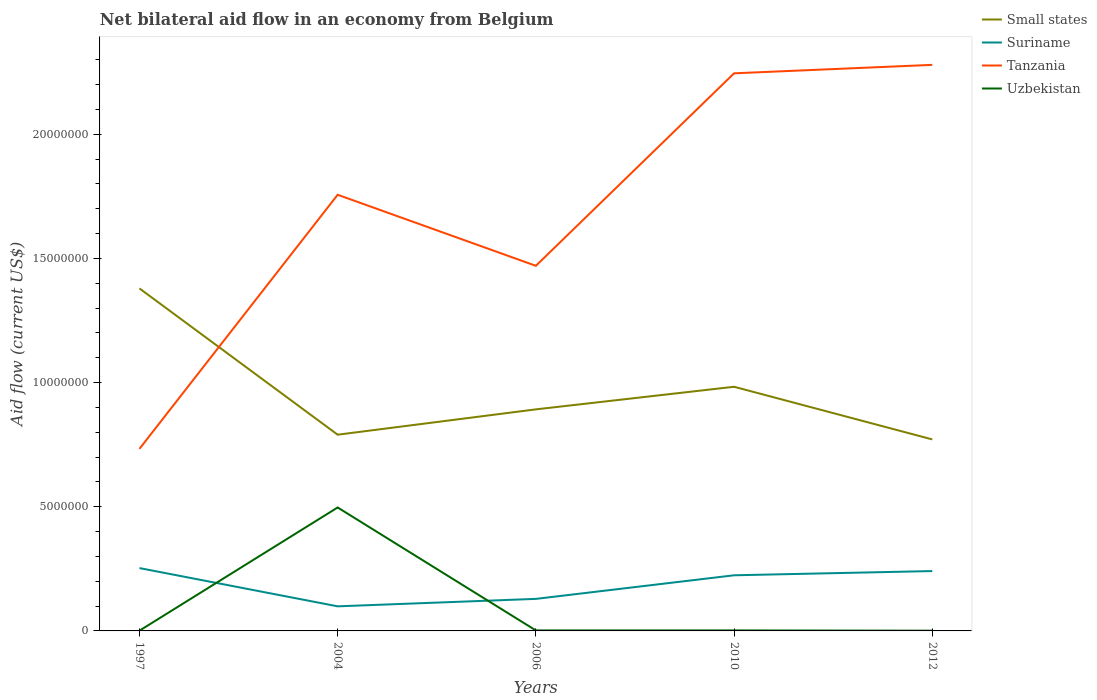Across all years, what is the maximum net bilateral aid flow in Suriname?
Your answer should be very brief. 9.90e+05. In which year was the net bilateral aid flow in Uzbekistan maximum?
Offer a terse response. 1997. What is the difference between the highest and the second highest net bilateral aid flow in Small states?
Your answer should be very brief. 6.08e+06. How many lines are there?
Ensure brevity in your answer.  4. Does the graph contain any zero values?
Offer a terse response. No. Does the graph contain grids?
Give a very brief answer. No. Where does the legend appear in the graph?
Give a very brief answer. Top right. How many legend labels are there?
Keep it short and to the point. 4. How are the legend labels stacked?
Offer a terse response. Vertical. What is the title of the graph?
Offer a very short reply. Net bilateral aid flow in an economy from Belgium. What is the label or title of the X-axis?
Make the answer very short. Years. What is the label or title of the Y-axis?
Ensure brevity in your answer.  Aid flow (current US$). What is the Aid flow (current US$) in Small states in 1997?
Provide a succinct answer. 1.38e+07. What is the Aid flow (current US$) in Suriname in 1997?
Keep it short and to the point. 2.53e+06. What is the Aid flow (current US$) in Tanzania in 1997?
Give a very brief answer. 7.33e+06. What is the Aid flow (current US$) in Small states in 2004?
Make the answer very short. 7.90e+06. What is the Aid flow (current US$) of Suriname in 2004?
Ensure brevity in your answer.  9.90e+05. What is the Aid flow (current US$) in Tanzania in 2004?
Provide a short and direct response. 1.76e+07. What is the Aid flow (current US$) in Uzbekistan in 2004?
Keep it short and to the point. 4.97e+06. What is the Aid flow (current US$) of Small states in 2006?
Make the answer very short. 8.92e+06. What is the Aid flow (current US$) of Suriname in 2006?
Your answer should be compact. 1.29e+06. What is the Aid flow (current US$) in Tanzania in 2006?
Provide a succinct answer. 1.47e+07. What is the Aid flow (current US$) of Uzbekistan in 2006?
Provide a short and direct response. 2.00e+04. What is the Aid flow (current US$) in Small states in 2010?
Keep it short and to the point. 9.83e+06. What is the Aid flow (current US$) in Suriname in 2010?
Provide a succinct answer. 2.24e+06. What is the Aid flow (current US$) in Tanzania in 2010?
Provide a short and direct response. 2.24e+07. What is the Aid flow (current US$) of Uzbekistan in 2010?
Make the answer very short. 2.00e+04. What is the Aid flow (current US$) in Small states in 2012?
Your answer should be compact. 7.71e+06. What is the Aid flow (current US$) in Suriname in 2012?
Your answer should be very brief. 2.41e+06. What is the Aid flow (current US$) of Tanzania in 2012?
Ensure brevity in your answer.  2.28e+07. What is the Aid flow (current US$) of Uzbekistan in 2012?
Give a very brief answer. 10000. Across all years, what is the maximum Aid flow (current US$) of Small states?
Your response must be concise. 1.38e+07. Across all years, what is the maximum Aid flow (current US$) of Suriname?
Ensure brevity in your answer.  2.53e+06. Across all years, what is the maximum Aid flow (current US$) in Tanzania?
Ensure brevity in your answer.  2.28e+07. Across all years, what is the maximum Aid flow (current US$) in Uzbekistan?
Your answer should be compact. 4.97e+06. Across all years, what is the minimum Aid flow (current US$) of Small states?
Give a very brief answer. 7.71e+06. Across all years, what is the minimum Aid flow (current US$) of Suriname?
Your answer should be compact. 9.90e+05. Across all years, what is the minimum Aid flow (current US$) in Tanzania?
Provide a short and direct response. 7.33e+06. What is the total Aid flow (current US$) in Small states in the graph?
Offer a terse response. 4.82e+07. What is the total Aid flow (current US$) in Suriname in the graph?
Provide a short and direct response. 9.46e+06. What is the total Aid flow (current US$) in Tanzania in the graph?
Your answer should be compact. 8.48e+07. What is the total Aid flow (current US$) of Uzbekistan in the graph?
Keep it short and to the point. 5.03e+06. What is the difference between the Aid flow (current US$) of Small states in 1997 and that in 2004?
Your answer should be compact. 5.89e+06. What is the difference between the Aid flow (current US$) of Suriname in 1997 and that in 2004?
Provide a succinct answer. 1.54e+06. What is the difference between the Aid flow (current US$) in Tanzania in 1997 and that in 2004?
Offer a very short reply. -1.02e+07. What is the difference between the Aid flow (current US$) in Uzbekistan in 1997 and that in 2004?
Your answer should be very brief. -4.96e+06. What is the difference between the Aid flow (current US$) in Small states in 1997 and that in 2006?
Your response must be concise. 4.87e+06. What is the difference between the Aid flow (current US$) of Suriname in 1997 and that in 2006?
Provide a short and direct response. 1.24e+06. What is the difference between the Aid flow (current US$) of Tanzania in 1997 and that in 2006?
Offer a terse response. -7.37e+06. What is the difference between the Aid flow (current US$) in Small states in 1997 and that in 2010?
Your answer should be compact. 3.96e+06. What is the difference between the Aid flow (current US$) of Tanzania in 1997 and that in 2010?
Offer a terse response. -1.51e+07. What is the difference between the Aid flow (current US$) in Uzbekistan in 1997 and that in 2010?
Make the answer very short. -10000. What is the difference between the Aid flow (current US$) of Small states in 1997 and that in 2012?
Give a very brief answer. 6.08e+06. What is the difference between the Aid flow (current US$) in Suriname in 1997 and that in 2012?
Give a very brief answer. 1.20e+05. What is the difference between the Aid flow (current US$) in Tanzania in 1997 and that in 2012?
Offer a very short reply. -1.55e+07. What is the difference between the Aid flow (current US$) in Small states in 2004 and that in 2006?
Your response must be concise. -1.02e+06. What is the difference between the Aid flow (current US$) in Suriname in 2004 and that in 2006?
Provide a succinct answer. -3.00e+05. What is the difference between the Aid flow (current US$) of Tanzania in 2004 and that in 2006?
Offer a terse response. 2.86e+06. What is the difference between the Aid flow (current US$) of Uzbekistan in 2004 and that in 2006?
Your answer should be very brief. 4.95e+06. What is the difference between the Aid flow (current US$) of Small states in 2004 and that in 2010?
Offer a very short reply. -1.93e+06. What is the difference between the Aid flow (current US$) of Suriname in 2004 and that in 2010?
Make the answer very short. -1.25e+06. What is the difference between the Aid flow (current US$) in Tanzania in 2004 and that in 2010?
Give a very brief answer. -4.89e+06. What is the difference between the Aid flow (current US$) in Uzbekistan in 2004 and that in 2010?
Make the answer very short. 4.95e+06. What is the difference between the Aid flow (current US$) in Small states in 2004 and that in 2012?
Your answer should be very brief. 1.90e+05. What is the difference between the Aid flow (current US$) of Suriname in 2004 and that in 2012?
Give a very brief answer. -1.42e+06. What is the difference between the Aid flow (current US$) of Tanzania in 2004 and that in 2012?
Provide a succinct answer. -5.23e+06. What is the difference between the Aid flow (current US$) of Uzbekistan in 2004 and that in 2012?
Keep it short and to the point. 4.96e+06. What is the difference between the Aid flow (current US$) of Small states in 2006 and that in 2010?
Give a very brief answer. -9.10e+05. What is the difference between the Aid flow (current US$) in Suriname in 2006 and that in 2010?
Provide a short and direct response. -9.50e+05. What is the difference between the Aid flow (current US$) of Tanzania in 2006 and that in 2010?
Keep it short and to the point. -7.75e+06. What is the difference between the Aid flow (current US$) of Small states in 2006 and that in 2012?
Provide a succinct answer. 1.21e+06. What is the difference between the Aid flow (current US$) in Suriname in 2006 and that in 2012?
Offer a very short reply. -1.12e+06. What is the difference between the Aid flow (current US$) of Tanzania in 2006 and that in 2012?
Ensure brevity in your answer.  -8.09e+06. What is the difference between the Aid flow (current US$) in Uzbekistan in 2006 and that in 2012?
Give a very brief answer. 10000. What is the difference between the Aid flow (current US$) of Small states in 2010 and that in 2012?
Provide a short and direct response. 2.12e+06. What is the difference between the Aid flow (current US$) in Uzbekistan in 2010 and that in 2012?
Keep it short and to the point. 10000. What is the difference between the Aid flow (current US$) in Small states in 1997 and the Aid flow (current US$) in Suriname in 2004?
Give a very brief answer. 1.28e+07. What is the difference between the Aid flow (current US$) of Small states in 1997 and the Aid flow (current US$) of Tanzania in 2004?
Your answer should be very brief. -3.77e+06. What is the difference between the Aid flow (current US$) of Small states in 1997 and the Aid flow (current US$) of Uzbekistan in 2004?
Give a very brief answer. 8.82e+06. What is the difference between the Aid flow (current US$) of Suriname in 1997 and the Aid flow (current US$) of Tanzania in 2004?
Give a very brief answer. -1.50e+07. What is the difference between the Aid flow (current US$) in Suriname in 1997 and the Aid flow (current US$) in Uzbekistan in 2004?
Offer a very short reply. -2.44e+06. What is the difference between the Aid flow (current US$) of Tanzania in 1997 and the Aid flow (current US$) of Uzbekistan in 2004?
Your answer should be compact. 2.36e+06. What is the difference between the Aid flow (current US$) in Small states in 1997 and the Aid flow (current US$) in Suriname in 2006?
Your answer should be very brief. 1.25e+07. What is the difference between the Aid flow (current US$) of Small states in 1997 and the Aid flow (current US$) of Tanzania in 2006?
Offer a very short reply. -9.10e+05. What is the difference between the Aid flow (current US$) in Small states in 1997 and the Aid flow (current US$) in Uzbekistan in 2006?
Your answer should be compact. 1.38e+07. What is the difference between the Aid flow (current US$) in Suriname in 1997 and the Aid flow (current US$) in Tanzania in 2006?
Your response must be concise. -1.22e+07. What is the difference between the Aid flow (current US$) of Suriname in 1997 and the Aid flow (current US$) of Uzbekistan in 2006?
Your answer should be compact. 2.51e+06. What is the difference between the Aid flow (current US$) in Tanzania in 1997 and the Aid flow (current US$) in Uzbekistan in 2006?
Offer a terse response. 7.31e+06. What is the difference between the Aid flow (current US$) of Small states in 1997 and the Aid flow (current US$) of Suriname in 2010?
Your answer should be compact. 1.16e+07. What is the difference between the Aid flow (current US$) in Small states in 1997 and the Aid flow (current US$) in Tanzania in 2010?
Provide a short and direct response. -8.66e+06. What is the difference between the Aid flow (current US$) in Small states in 1997 and the Aid flow (current US$) in Uzbekistan in 2010?
Your answer should be compact. 1.38e+07. What is the difference between the Aid flow (current US$) in Suriname in 1997 and the Aid flow (current US$) in Tanzania in 2010?
Offer a very short reply. -1.99e+07. What is the difference between the Aid flow (current US$) of Suriname in 1997 and the Aid flow (current US$) of Uzbekistan in 2010?
Your response must be concise. 2.51e+06. What is the difference between the Aid flow (current US$) of Tanzania in 1997 and the Aid flow (current US$) of Uzbekistan in 2010?
Offer a terse response. 7.31e+06. What is the difference between the Aid flow (current US$) of Small states in 1997 and the Aid flow (current US$) of Suriname in 2012?
Make the answer very short. 1.14e+07. What is the difference between the Aid flow (current US$) of Small states in 1997 and the Aid flow (current US$) of Tanzania in 2012?
Provide a short and direct response. -9.00e+06. What is the difference between the Aid flow (current US$) of Small states in 1997 and the Aid flow (current US$) of Uzbekistan in 2012?
Offer a very short reply. 1.38e+07. What is the difference between the Aid flow (current US$) in Suriname in 1997 and the Aid flow (current US$) in Tanzania in 2012?
Your response must be concise. -2.03e+07. What is the difference between the Aid flow (current US$) of Suriname in 1997 and the Aid flow (current US$) of Uzbekistan in 2012?
Your response must be concise. 2.52e+06. What is the difference between the Aid flow (current US$) of Tanzania in 1997 and the Aid flow (current US$) of Uzbekistan in 2012?
Your response must be concise. 7.32e+06. What is the difference between the Aid flow (current US$) of Small states in 2004 and the Aid flow (current US$) of Suriname in 2006?
Your answer should be very brief. 6.61e+06. What is the difference between the Aid flow (current US$) in Small states in 2004 and the Aid flow (current US$) in Tanzania in 2006?
Provide a short and direct response. -6.80e+06. What is the difference between the Aid flow (current US$) of Small states in 2004 and the Aid flow (current US$) of Uzbekistan in 2006?
Offer a terse response. 7.88e+06. What is the difference between the Aid flow (current US$) of Suriname in 2004 and the Aid flow (current US$) of Tanzania in 2006?
Give a very brief answer. -1.37e+07. What is the difference between the Aid flow (current US$) of Suriname in 2004 and the Aid flow (current US$) of Uzbekistan in 2006?
Make the answer very short. 9.70e+05. What is the difference between the Aid flow (current US$) of Tanzania in 2004 and the Aid flow (current US$) of Uzbekistan in 2006?
Keep it short and to the point. 1.75e+07. What is the difference between the Aid flow (current US$) in Small states in 2004 and the Aid flow (current US$) in Suriname in 2010?
Your response must be concise. 5.66e+06. What is the difference between the Aid flow (current US$) of Small states in 2004 and the Aid flow (current US$) of Tanzania in 2010?
Your answer should be compact. -1.46e+07. What is the difference between the Aid flow (current US$) of Small states in 2004 and the Aid flow (current US$) of Uzbekistan in 2010?
Provide a short and direct response. 7.88e+06. What is the difference between the Aid flow (current US$) of Suriname in 2004 and the Aid flow (current US$) of Tanzania in 2010?
Ensure brevity in your answer.  -2.15e+07. What is the difference between the Aid flow (current US$) of Suriname in 2004 and the Aid flow (current US$) of Uzbekistan in 2010?
Your response must be concise. 9.70e+05. What is the difference between the Aid flow (current US$) of Tanzania in 2004 and the Aid flow (current US$) of Uzbekistan in 2010?
Provide a short and direct response. 1.75e+07. What is the difference between the Aid flow (current US$) in Small states in 2004 and the Aid flow (current US$) in Suriname in 2012?
Offer a very short reply. 5.49e+06. What is the difference between the Aid flow (current US$) of Small states in 2004 and the Aid flow (current US$) of Tanzania in 2012?
Offer a very short reply. -1.49e+07. What is the difference between the Aid flow (current US$) of Small states in 2004 and the Aid flow (current US$) of Uzbekistan in 2012?
Give a very brief answer. 7.89e+06. What is the difference between the Aid flow (current US$) in Suriname in 2004 and the Aid flow (current US$) in Tanzania in 2012?
Ensure brevity in your answer.  -2.18e+07. What is the difference between the Aid flow (current US$) in Suriname in 2004 and the Aid flow (current US$) in Uzbekistan in 2012?
Your response must be concise. 9.80e+05. What is the difference between the Aid flow (current US$) of Tanzania in 2004 and the Aid flow (current US$) of Uzbekistan in 2012?
Offer a terse response. 1.76e+07. What is the difference between the Aid flow (current US$) of Small states in 2006 and the Aid flow (current US$) of Suriname in 2010?
Make the answer very short. 6.68e+06. What is the difference between the Aid flow (current US$) of Small states in 2006 and the Aid flow (current US$) of Tanzania in 2010?
Offer a terse response. -1.35e+07. What is the difference between the Aid flow (current US$) in Small states in 2006 and the Aid flow (current US$) in Uzbekistan in 2010?
Your response must be concise. 8.90e+06. What is the difference between the Aid flow (current US$) of Suriname in 2006 and the Aid flow (current US$) of Tanzania in 2010?
Make the answer very short. -2.12e+07. What is the difference between the Aid flow (current US$) of Suriname in 2006 and the Aid flow (current US$) of Uzbekistan in 2010?
Provide a succinct answer. 1.27e+06. What is the difference between the Aid flow (current US$) of Tanzania in 2006 and the Aid flow (current US$) of Uzbekistan in 2010?
Give a very brief answer. 1.47e+07. What is the difference between the Aid flow (current US$) in Small states in 2006 and the Aid flow (current US$) in Suriname in 2012?
Your answer should be compact. 6.51e+06. What is the difference between the Aid flow (current US$) of Small states in 2006 and the Aid flow (current US$) of Tanzania in 2012?
Provide a succinct answer. -1.39e+07. What is the difference between the Aid flow (current US$) in Small states in 2006 and the Aid flow (current US$) in Uzbekistan in 2012?
Your response must be concise. 8.91e+06. What is the difference between the Aid flow (current US$) of Suriname in 2006 and the Aid flow (current US$) of Tanzania in 2012?
Make the answer very short. -2.15e+07. What is the difference between the Aid flow (current US$) in Suriname in 2006 and the Aid flow (current US$) in Uzbekistan in 2012?
Offer a very short reply. 1.28e+06. What is the difference between the Aid flow (current US$) of Tanzania in 2006 and the Aid flow (current US$) of Uzbekistan in 2012?
Offer a terse response. 1.47e+07. What is the difference between the Aid flow (current US$) of Small states in 2010 and the Aid flow (current US$) of Suriname in 2012?
Give a very brief answer. 7.42e+06. What is the difference between the Aid flow (current US$) of Small states in 2010 and the Aid flow (current US$) of Tanzania in 2012?
Offer a very short reply. -1.30e+07. What is the difference between the Aid flow (current US$) in Small states in 2010 and the Aid flow (current US$) in Uzbekistan in 2012?
Your answer should be compact. 9.82e+06. What is the difference between the Aid flow (current US$) of Suriname in 2010 and the Aid flow (current US$) of Tanzania in 2012?
Give a very brief answer. -2.06e+07. What is the difference between the Aid flow (current US$) of Suriname in 2010 and the Aid flow (current US$) of Uzbekistan in 2012?
Make the answer very short. 2.23e+06. What is the difference between the Aid flow (current US$) in Tanzania in 2010 and the Aid flow (current US$) in Uzbekistan in 2012?
Your answer should be compact. 2.24e+07. What is the average Aid flow (current US$) of Small states per year?
Your answer should be compact. 9.63e+06. What is the average Aid flow (current US$) of Suriname per year?
Give a very brief answer. 1.89e+06. What is the average Aid flow (current US$) of Tanzania per year?
Keep it short and to the point. 1.70e+07. What is the average Aid flow (current US$) of Uzbekistan per year?
Give a very brief answer. 1.01e+06. In the year 1997, what is the difference between the Aid flow (current US$) of Small states and Aid flow (current US$) of Suriname?
Provide a succinct answer. 1.13e+07. In the year 1997, what is the difference between the Aid flow (current US$) in Small states and Aid flow (current US$) in Tanzania?
Your response must be concise. 6.46e+06. In the year 1997, what is the difference between the Aid flow (current US$) in Small states and Aid flow (current US$) in Uzbekistan?
Your response must be concise. 1.38e+07. In the year 1997, what is the difference between the Aid flow (current US$) in Suriname and Aid flow (current US$) in Tanzania?
Offer a terse response. -4.80e+06. In the year 1997, what is the difference between the Aid flow (current US$) in Suriname and Aid flow (current US$) in Uzbekistan?
Provide a short and direct response. 2.52e+06. In the year 1997, what is the difference between the Aid flow (current US$) in Tanzania and Aid flow (current US$) in Uzbekistan?
Your answer should be compact. 7.32e+06. In the year 2004, what is the difference between the Aid flow (current US$) of Small states and Aid flow (current US$) of Suriname?
Make the answer very short. 6.91e+06. In the year 2004, what is the difference between the Aid flow (current US$) of Small states and Aid flow (current US$) of Tanzania?
Your response must be concise. -9.66e+06. In the year 2004, what is the difference between the Aid flow (current US$) of Small states and Aid flow (current US$) of Uzbekistan?
Give a very brief answer. 2.93e+06. In the year 2004, what is the difference between the Aid flow (current US$) in Suriname and Aid flow (current US$) in Tanzania?
Offer a very short reply. -1.66e+07. In the year 2004, what is the difference between the Aid flow (current US$) of Suriname and Aid flow (current US$) of Uzbekistan?
Provide a succinct answer. -3.98e+06. In the year 2004, what is the difference between the Aid flow (current US$) in Tanzania and Aid flow (current US$) in Uzbekistan?
Offer a very short reply. 1.26e+07. In the year 2006, what is the difference between the Aid flow (current US$) of Small states and Aid flow (current US$) of Suriname?
Provide a succinct answer. 7.63e+06. In the year 2006, what is the difference between the Aid flow (current US$) of Small states and Aid flow (current US$) of Tanzania?
Your response must be concise. -5.78e+06. In the year 2006, what is the difference between the Aid flow (current US$) in Small states and Aid flow (current US$) in Uzbekistan?
Give a very brief answer. 8.90e+06. In the year 2006, what is the difference between the Aid flow (current US$) of Suriname and Aid flow (current US$) of Tanzania?
Your answer should be very brief. -1.34e+07. In the year 2006, what is the difference between the Aid flow (current US$) in Suriname and Aid flow (current US$) in Uzbekistan?
Provide a succinct answer. 1.27e+06. In the year 2006, what is the difference between the Aid flow (current US$) in Tanzania and Aid flow (current US$) in Uzbekistan?
Your response must be concise. 1.47e+07. In the year 2010, what is the difference between the Aid flow (current US$) of Small states and Aid flow (current US$) of Suriname?
Your answer should be very brief. 7.59e+06. In the year 2010, what is the difference between the Aid flow (current US$) in Small states and Aid flow (current US$) in Tanzania?
Your response must be concise. -1.26e+07. In the year 2010, what is the difference between the Aid flow (current US$) of Small states and Aid flow (current US$) of Uzbekistan?
Your response must be concise. 9.81e+06. In the year 2010, what is the difference between the Aid flow (current US$) of Suriname and Aid flow (current US$) of Tanzania?
Provide a succinct answer. -2.02e+07. In the year 2010, what is the difference between the Aid flow (current US$) in Suriname and Aid flow (current US$) in Uzbekistan?
Make the answer very short. 2.22e+06. In the year 2010, what is the difference between the Aid flow (current US$) in Tanzania and Aid flow (current US$) in Uzbekistan?
Offer a terse response. 2.24e+07. In the year 2012, what is the difference between the Aid flow (current US$) of Small states and Aid flow (current US$) of Suriname?
Give a very brief answer. 5.30e+06. In the year 2012, what is the difference between the Aid flow (current US$) of Small states and Aid flow (current US$) of Tanzania?
Offer a terse response. -1.51e+07. In the year 2012, what is the difference between the Aid flow (current US$) in Small states and Aid flow (current US$) in Uzbekistan?
Ensure brevity in your answer.  7.70e+06. In the year 2012, what is the difference between the Aid flow (current US$) of Suriname and Aid flow (current US$) of Tanzania?
Make the answer very short. -2.04e+07. In the year 2012, what is the difference between the Aid flow (current US$) of Suriname and Aid flow (current US$) of Uzbekistan?
Your response must be concise. 2.40e+06. In the year 2012, what is the difference between the Aid flow (current US$) in Tanzania and Aid flow (current US$) in Uzbekistan?
Offer a very short reply. 2.28e+07. What is the ratio of the Aid flow (current US$) in Small states in 1997 to that in 2004?
Ensure brevity in your answer.  1.75. What is the ratio of the Aid flow (current US$) of Suriname in 1997 to that in 2004?
Give a very brief answer. 2.56. What is the ratio of the Aid flow (current US$) of Tanzania in 1997 to that in 2004?
Your response must be concise. 0.42. What is the ratio of the Aid flow (current US$) in Uzbekistan in 1997 to that in 2004?
Your answer should be very brief. 0. What is the ratio of the Aid flow (current US$) of Small states in 1997 to that in 2006?
Provide a short and direct response. 1.55. What is the ratio of the Aid flow (current US$) of Suriname in 1997 to that in 2006?
Ensure brevity in your answer.  1.96. What is the ratio of the Aid flow (current US$) in Tanzania in 1997 to that in 2006?
Provide a succinct answer. 0.5. What is the ratio of the Aid flow (current US$) in Small states in 1997 to that in 2010?
Offer a terse response. 1.4. What is the ratio of the Aid flow (current US$) in Suriname in 1997 to that in 2010?
Make the answer very short. 1.13. What is the ratio of the Aid flow (current US$) in Tanzania in 1997 to that in 2010?
Make the answer very short. 0.33. What is the ratio of the Aid flow (current US$) in Small states in 1997 to that in 2012?
Make the answer very short. 1.79. What is the ratio of the Aid flow (current US$) of Suriname in 1997 to that in 2012?
Offer a very short reply. 1.05. What is the ratio of the Aid flow (current US$) of Tanzania in 1997 to that in 2012?
Provide a succinct answer. 0.32. What is the ratio of the Aid flow (current US$) in Small states in 2004 to that in 2006?
Offer a terse response. 0.89. What is the ratio of the Aid flow (current US$) of Suriname in 2004 to that in 2006?
Ensure brevity in your answer.  0.77. What is the ratio of the Aid flow (current US$) in Tanzania in 2004 to that in 2006?
Your answer should be compact. 1.19. What is the ratio of the Aid flow (current US$) in Uzbekistan in 2004 to that in 2006?
Offer a very short reply. 248.5. What is the ratio of the Aid flow (current US$) in Small states in 2004 to that in 2010?
Your answer should be compact. 0.8. What is the ratio of the Aid flow (current US$) in Suriname in 2004 to that in 2010?
Ensure brevity in your answer.  0.44. What is the ratio of the Aid flow (current US$) of Tanzania in 2004 to that in 2010?
Provide a succinct answer. 0.78. What is the ratio of the Aid flow (current US$) of Uzbekistan in 2004 to that in 2010?
Your response must be concise. 248.5. What is the ratio of the Aid flow (current US$) in Small states in 2004 to that in 2012?
Your response must be concise. 1.02. What is the ratio of the Aid flow (current US$) in Suriname in 2004 to that in 2012?
Offer a very short reply. 0.41. What is the ratio of the Aid flow (current US$) of Tanzania in 2004 to that in 2012?
Keep it short and to the point. 0.77. What is the ratio of the Aid flow (current US$) in Uzbekistan in 2004 to that in 2012?
Keep it short and to the point. 497. What is the ratio of the Aid flow (current US$) of Small states in 2006 to that in 2010?
Your answer should be very brief. 0.91. What is the ratio of the Aid flow (current US$) of Suriname in 2006 to that in 2010?
Give a very brief answer. 0.58. What is the ratio of the Aid flow (current US$) of Tanzania in 2006 to that in 2010?
Provide a short and direct response. 0.65. What is the ratio of the Aid flow (current US$) in Small states in 2006 to that in 2012?
Give a very brief answer. 1.16. What is the ratio of the Aid flow (current US$) in Suriname in 2006 to that in 2012?
Make the answer very short. 0.54. What is the ratio of the Aid flow (current US$) of Tanzania in 2006 to that in 2012?
Keep it short and to the point. 0.65. What is the ratio of the Aid flow (current US$) of Small states in 2010 to that in 2012?
Keep it short and to the point. 1.27. What is the ratio of the Aid flow (current US$) in Suriname in 2010 to that in 2012?
Your answer should be compact. 0.93. What is the ratio of the Aid flow (current US$) in Tanzania in 2010 to that in 2012?
Give a very brief answer. 0.99. What is the ratio of the Aid flow (current US$) of Uzbekistan in 2010 to that in 2012?
Your answer should be very brief. 2. What is the difference between the highest and the second highest Aid flow (current US$) in Small states?
Make the answer very short. 3.96e+06. What is the difference between the highest and the second highest Aid flow (current US$) of Tanzania?
Keep it short and to the point. 3.40e+05. What is the difference between the highest and the second highest Aid flow (current US$) in Uzbekistan?
Offer a very short reply. 4.95e+06. What is the difference between the highest and the lowest Aid flow (current US$) in Small states?
Your answer should be very brief. 6.08e+06. What is the difference between the highest and the lowest Aid flow (current US$) in Suriname?
Provide a succinct answer. 1.54e+06. What is the difference between the highest and the lowest Aid flow (current US$) of Tanzania?
Make the answer very short. 1.55e+07. What is the difference between the highest and the lowest Aid flow (current US$) of Uzbekistan?
Keep it short and to the point. 4.96e+06. 